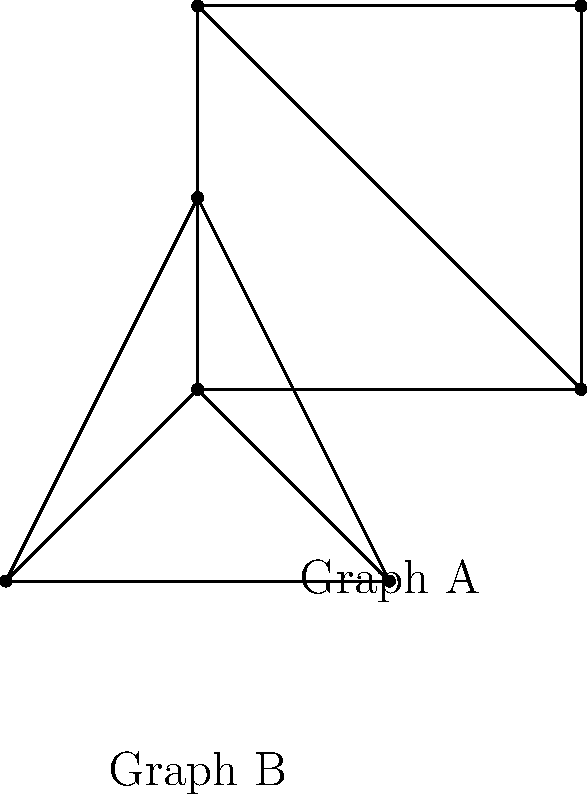Consider the two graphs A and B representing the architectural layouts of two lesser-known Roman ruins in Rome. Are these graphs isomorphic? If so, provide a bijective mapping between the vertices of the two graphs that preserves the edge structure. If not, explain why they are not isomorphic. To determine if the graphs are isomorphic, we need to check if there exists a bijective mapping between the vertices that preserves the edge structure. Let's analyze this step-by-step:

1. Both graphs have 4 vertices, which is a necessary (but not sufficient) condition for isomorphism.

2. Let's examine the degree of each vertex in both graphs:
   Graph A: All vertices have degree 3
   Graph B: Three vertices have degree 3, and one vertex has degree 2

3. Since the degree sequences of the two graphs are different, they cannot be isomorphic. In an isomorphic mapping, the degrees of corresponding vertices must be the same.

4. Additionally, Graph A contains a cycle of length 4 (square shape), while Graph B does not have a cycle of length 4.

5. Graph B has a vertex of degree 2 (the center vertex), while Graph A does not have any vertex of degree 2.

These differences in structure prove that the two graphs are not isomorphic, despite having the same number of vertices and edges. The architectural layouts they represent are fundamentally different in their connectivity and cannot be mapped to each other while preserving the edge structure.
Answer: Not isomorphic 